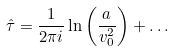Convert formula to latex. <formula><loc_0><loc_0><loc_500><loc_500>\hat { \tau } = \frac { 1 } { 2 \pi i } \ln \left ( \frac { a } { v _ { 0 } ^ { 2 } } \right ) + \dots</formula> 